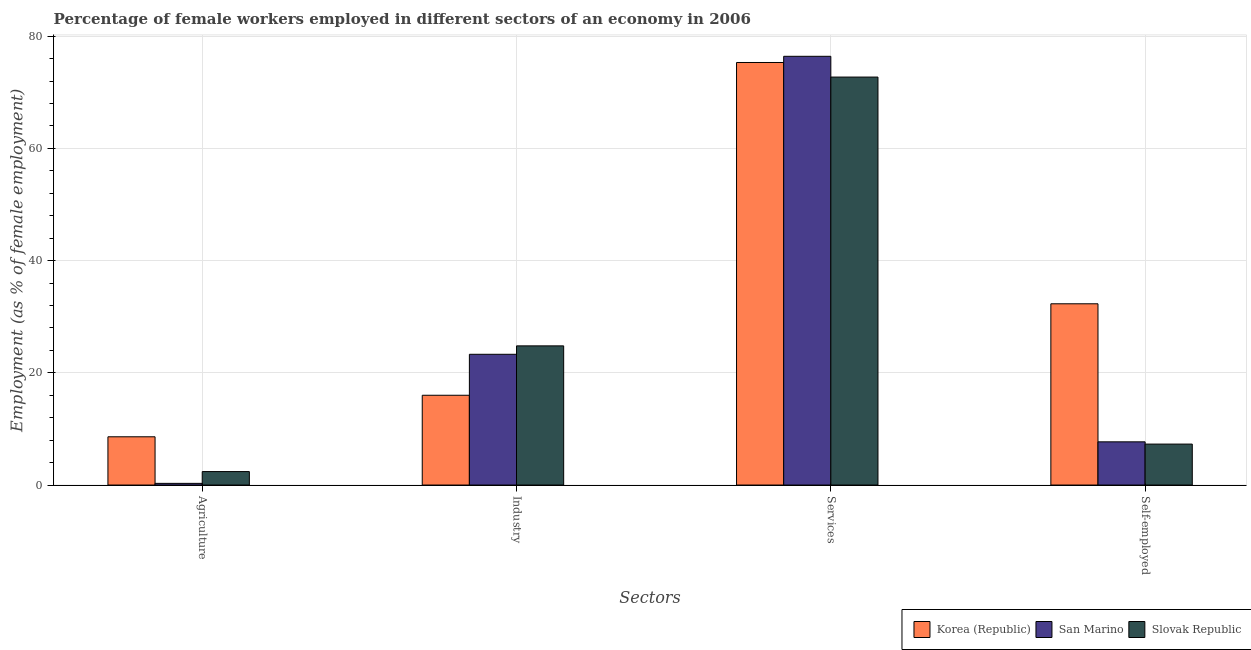How many different coloured bars are there?
Ensure brevity in your answer.  3. How many groups of bars are there?
Ensure brevity in your answer.  4. Are the number of bars per tick equal to the number of legend labels?
Provide a short and direct response. Yes. Are the number of bars on each tick of the X-axis equal?
Offer a terse response. Yes. How many bars are there on the 3rd tick from the left?
Provide a short and direct response. 3. What is the label of the 4th group of bars from the left?
Your answer should be compact. Self-employed. What is the percentage of female workers in industry in Slovak Republic?
Your answer should be compact. 24.8. Across all countries, what is the maximum percentage of female workers in services?
Offer a terse response. 76.4. Across all countries, what is the minimum percentage of female workers in services?
Your answer should be very brief. 72.7. In which country was the percentage of female workers in services maximum?
Provide a succinct answer. San Marino. What is the total percentage of female workers in services in the graph?
Your answer should be compact. 224.4. What is the difference between the percentage of female workers in services in Slovak Republic and that in San Marino?
Make the answer very short. -3.7. What is the difference between the percentage of female workers in industry in Korea (Republic) and the percentage of self employed female workers in Slovak Republic?
Your answer should be compact. 8.7. What is the average percentage of female workers in industry per country?
Your answer should be compact. 21.37. What is the difference between the percentage of female workers in industry and percentage of self employed female workers in Slovak Republic?
Keep it short and to the point. 17.5. What is the ratio of the percentage of self employed female workers in Slovak Republic to that in San Marino?
Provide a short and direct response. 0.95. Is the percentage of self employed female workers in San Marino less than that in Korea (Republic)?
Offer a very short reply. Yes. What is the difference between the highest and the second highest percentage of female workers in agriculture?
Ensure brevity in your answer.  6.2. What is the difference between the highest and the lowest percentage of female workers in industry?
Your answer should be very brief. 8.8. Is the sum of the percentage of female workers in services in San Marino and Slovak Republic greater than the maximum percentage of female workers in agriculture across all countries?
Your answer should be compact. Yes. What does the 2nd bar from the right in Industry represents?
Your response must be concise. San Marino. Is it the case that in every country, the sum of the percentage of female workers in agriculture and percentage of female workers in industry is greater than the percentage of female workers in services?
Provide a short and direct response. No. Are all the bars in the graph horizontal?
Provide a short and direct response. No. What is the difference between two consecutive major ticks on the Y-axis?
Ensure brevity in your answer.  20. Are the values on the major ticks of Y-axis written in scientific E-notation?
Give a very brief answer. No. Does the graph contain any zero values?
Offer a terse response. No. Does the graph contain grids?
Give a very brief answer. Yes. Where does the legend appear in the graph?
Your answer should be very brief. Bottom right. How many legend labels are there?
Provide a short and direct response. 3. How are the legend labels stacked?
Provide a short and direct response. Horizontal. What is the title of the graph?
Provide a short and direct response. Percentage of female workers employed in different sectors of an economy in 2006. Does "Suriname" appear as one of the legend labels in the graph?
Make the answer very short. No. What is the label or title of the X-axis?
Give a very brief answer. Sectors. What is the label or title of the Y-axis?
Provide a short and direct response. Employment (as % of female employment). What is the Employment (as % of female employment) in Korea (Republic) in Agriculture?
Your answer should be compact. 8.6. What is the Employment (as % of female employment) of San Marino in Agriculture?
Your response must be concise. 0.3. What is the Employment (as % of female employment) of Slovak Republic in Agriculture?
Make the answer very short. 2.4. What is the Employment (as % of female employment) of San Marino in Industry?
Your response must be concise. 23.3. What is the Employment (as % of female employment) of Slovak Republic in Industry?
Make the answer very short. 24.8. What is the Employment (as % of female employment) of Korea (Republic) in Services?
Provide a short and direct response. 75.3. What is the Employment (as % of female employment) in San Marino in Services?
Provide a succinct answer. 76.4. What is the Employment (as % of female employment) of Slovak Republic in Services?
Make the answer very short. 72.7. What is the Employment (as % of female employment) in Korea (Republic) in Self-employed?
Offer a very short reply. 32.3. What is the Employment (as % of female employment) in San Marino in Self-employed?
Your answer should be compact. 7.7. What is the Employment (as % of female employment) in Slovak Republic in Self-employed?
Your answer should be compact. 7.3. Across all Sectors, what is the maximum Employment (as % of female employment) in Korea (Republic)?
Your response must be concise. 75.3. Across all Sectors, what is the maximum Employment (as % of female employment) of San Marino?
Your answer should be compact. 76.4. Across all Sectors, what is the maximum Employment (as % of female employment) in Slovak Republic?
Make the answer very short. 72.7. Across all Sectors, what is the minimum Employment (as % of female employment) in Korea (Republic)?
Your response must be concise. 8.6. Across all Sectors, what is the minimum Employment (as % of female employment) of San Marino?
Provide a short and direct response. 0.3. Across all Sectors, what is the minimum Employment (as % of female employment) in Slovak Republic?
Offer a very short reply. 2.4. What is the total Employment (as % of female employment) of Korea (Republic) in the graph?
Offer a terse response. 132.2. What is the total Employment (as % of female employment) of San Marino in the graph?
Offer a terse response. 107.7. What is the total Employment (as % of female employment) of Slovak Republic in the graph?
Offer a very short reply. 107.2. What is the difference between the Employment (as % of female employment) in Slovak Republic in Agriculture and that in Industry?
Your response must be concise. -22.4. What is the difference between the Employment (as % of female employment) of Korea (Republic) in Agriculture and that in Services?
Offer a terse response. -66.7. What is the difference between the Employment (as % of female employment) of San Marino in Agriculture and that in Services?
Provide a short and direct response. -76.1. What is the difference between the Employment (as % of female employment) in Slovak Republic in Agriculture and that in Services?
Keep it short and to the point. -70.3. What is the difference between the Employment (as % of female employment) in Korea (Republic) in Agriculture and that in Self-employed?
Keep it short and to the point. -23.7. What is the difference between the Employment (as % of female employment) of San Marino in Agriculture and that in Self-employed?
Ensure brevity in your answer.  -7.4. What is the difference between the Employment (as % of female employment) in Korea (Republic) in Industry and that in Services?
Provide a succinct answer. -59.3. What is the difference between the Employment (as % of female employment) in San Marino in Industry and that in Services?
Ensure brevity in your answer.  -53.1. What is the difference between the Employment (as % of female employment) of Slovak Republic in Industry and that in Services?
Provide a short and direct response. -47.9. What is the difference between the Employment (as % of female employment) of Korea (Republic) in Industry and that in Self-employed?
Provide a short and direct response. -16.3. What is the difference between the Employment (as % of female employment) of San Marino in Services and that in Self-employed?
Make the answer very short. 68.7. What is the difference between the Employment (as % of female employment) of Slovak Republic in Services and that in Self-employed?
Offer a terse response. 65.4. What is the difference between the Employment (as % of female employment) of Korea (Republic) in Agriculture and the Employment (as % of female employment) of San Marino in Industry?
Your answer should be very brief. -14.7. What is the difference between the Employment (as % of female employment) of Korea (Republic) in Agriculture and the Employment (as % of female employment) of Slovak Republic in Industry?
Provide a short and direct response. -16.2. What is the difference between the Employment (as % of female employment) of San Marino in Agriculture and the Employment (as % of female employment) of Slovak Republic in Industry?
Ensure brevity in your answer.  -24.5. What is the difference between the Employment (as % of female employment) of Korea (Republic) in Agriculture and the Employment (as % of female employment) of San Marino in Services?
Your answer should be very brief. -67.8. What is the difference between the Employment (as % of female employment) of Korea (Republic) in Agriculture and the Employment (as % of female employment) of Slovak Republic in Services?
Provide a short and direct response. -64.1. What is the difference between the Employment (as % of female employment) of San Marino in Agriculture and the Employment (as % of female employment) of Slovak Republic in Services?
Provide a succinct answer. -72.4. What is the difference between the Employment (as % of female employment) in Korea (Republic) in Agriculture and the Employment (as % of female employment) in Slovak Republic in Self-employed?
Your answer should be compact. 1.3. What is the difference between the Employment (as % of female employment) in San Marino in Agriculture and the Employment (as % of female employment) in Slovak Republic in Self-employed?
Make the answer very short. -7. What is the difference between the Employment (as % of female employment) of Korea (Republic) in Industry and the Employment (as % of female employment) of San Marino in Services?
Provide a succinct answer. -60.4. What is the difference between the Employment (as % of female employment) in Korea (Republic) in Industry and the Employment (as % of female employment) in Slovak Republic in Services?
Ensure brevity in your answer.  -56.7. What is the difference between the Employment (as % of female employment) in San Marino in Industry and the Employment (as % of female employment) in Slovak Republic in Services?
Give a very brief answer. -49.4. What is the difference between the Employment (as % of female employment) in Korea (Republic) in Industry and the Employment (as % of female employment) in Slovak Republic in Self-employed?
Provide a succinct answer. 8.7. What is the difference between the Employment (as % of female employment) in San Marino in Industry and the Employment (as % of female employment) in Slovak Republic in Self-employed?
Offer a terse response. 16. What is the difference between the Employment (as % of female employment) in Korea (Republic) in Services and the Employment (as % of female employment) in San Marino in Self-employed?
Ensure brevity in your answer.  67.6. What is the difference between the Employment (as % of female employment) of Korea (Republic) in Services and the Employment (as % of female employment) of Slovak Republic in Self-employed?
Offer a very short reply. 68. What is the difference between the Employment (as % of female employment) in San Marino in Services and the Employment (as % of female employment) in Slovak Republic in Self-employed?
Offer a terse response. 69.1. What is the average Employment (as % of female employment) of Korea (Republic) per Sectors?
Provide a short and direct response. 33.05. What is the average Employment (as % of female employment) in San Marino per Sectors?
Offer a very short reply. 26.93. What is the average Employment (as % of female employment) of Slovak Republic per Sectors?
Keep it short and to the point. 26.8. What is the difference between the Employment (as % of female employment) of Korea (Republic) and Employment (as % of female employment) of Slovak Republic in Agriculture?
Keep it short and to the point. 6.2. What is the difference between the Employment (as % of female employment) of San Marino and Employment (as % of female employment) of Slovak Republic in Agriculture?
Offer a very short reply. -2.1. What is the difference between the Employment (as % of female employment) of Korea (Republic) and Employment (as % of female employment) of San Marino in Industry?
Offer a very short reply. -7.3. What is the difference between the Employment (as % of female employment) of Korea (Republic) and Employment (as % of female employment) of San Marino in Services?
Provide a short and direct response. -1.1. What is the difference between the Employment (as % of female employment) in Korea (Republic) and Employment (as % of female employment) in Slovak Republic in Services?
Your response must be concise. 2.6. What is the difference between the Employment (as % of female employment) in San Marino and Employment (as % of female employment) in Slovak Republic in Services?
Provide a succinct answer. 3.7. What is the difference between the Employment (as % of female employment) of Korea (Republic) and Employment (as % of female employment) of San Marino in Self-employed?
Your answer should be very brief. 24.6. What is the difference between the Employment (as % of female employment) in Korea (Republic) and Employment (as % of female employment) in Slovak Republic in Self-employed?
Make the answer very short. 25. What is the difference between the Employment (as % of female employment) of San Marino and Employment (as % of female employment) of Slovak Republic in Self-employed?
Keep it short and to the point. 0.4. What is the ratio of the Employment (as % of female employment) of Korea (Republic) in Agriculture to that in Industry?
Offer a terse response. 0.54. What is the ratio of the Employment (as % of female employment) in San Marino in Agriculture to that in Industry?
Keep it short and to the point. 0.01. What is the ratio of the Employment (as % of female employment) in Slovak Republic in Agriculture to that in Industry?
Your answer should be compact. 0.1. What is the ratio of the Employment (as % of female employment) of Korea (Republic) in Agriculture to that in Services?
Your response must be concise. 0.11. What is the ratio of the Employment (as % of female employment) of San Marino in Agriculture to that in Services?
Provide a succinct answer. 0. What is the ratio of the Employment (as % of female employment) in Slovak Republic in Agriculture to that in Services?
Your answer should be very brief. 0.03. What is the ratio of the Employment (as % of female employment) in Korea (Republic) in Agriculture to that in Self-employed?
Ensure brevity in your answer.  0.27. What is the ratio of the Employment (as % of female employment) of San Marino in Agriculture to that in Self-employed?
Provide a succinct answer. 0.04. What is the ratio of the Employment (as % of female employment) of Slovak Republic in Agriculture to that in Self-employed?
Make the answer very short. 0.33. What is the ratio of the Employment (as % of female employment) in Korea (Republic) in Industry to that in Services?
Your answer should be compact. 0.21. What is the ratio of the Employment (as % of female employment) in San Marino in Industry to that in Services?
Give a very brief answer. 0.3. What is the ratio of the Employment (as % of female employment) in Slovak Republic in Industry to that in Services?
Provide a succinct answer. 0.34. What is the ratio of the Employment (as % of female employment) of Korea (Republic) in Industry to that in Self-employed?
Offer a terse response. 0.5. What is the ratio of the Employment (as % of female employment) of San Marino in Industry to that in Self-employed?
Provide a succinct answer. 3.03. What is the ratio of the Employment (as % of female employment) of Slovak Republic in Industry to that in Self-employed?
Offer a very short reply. 3.4. What is the ratio of the Employment (as % of female employment) in Korea (Republic) in Services to that in Self-employed?
Give a very brief answer. 2.33. What is the ratio of the Employment (as % of female employment) in San Marino in Services to that in Self-employed?
Your answer should be compact. 9.92. What is the ratio of the Employment (as % of female employment) in Slovak Republic in Services to that in Self-employed?
Give a very brief answer. 9.96. What is the difference between the highest and the second highest Employment (as % of female employment) in Korea (Republic)?
Your answer should be very brief. 43. What is the difference between the highest and the second highest Employment (as % of female employment) of San Marino?
Give a very brief answer. 53.1. What is the difference between the highest and the second highest Employment (as % of female employment) of Slovak Republic?
Provide a short and direct response. 47.9. What is the difference between the highest and the lowest Employment (as % of female employment) of Korea (Republic)?
Provide a short and direct response. 66.7. What is the difference between the highest and the lowest Employment (as % of female employment) in San Marino?
Offer a terse response. 76.1. What is the difference between the highest and the lowest Employment (as % of female employment) of Slovak Republic?
Your response must be concise. 70.3. 